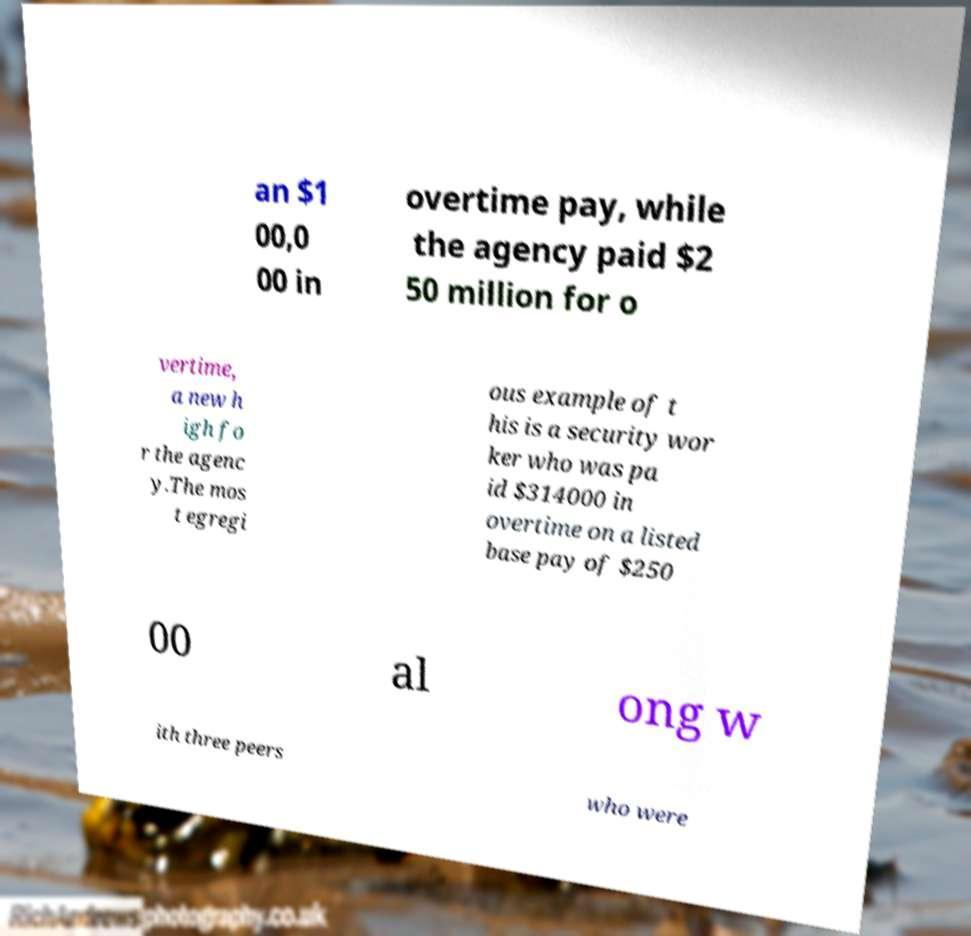Can you accurately transcribe the text from the provided image for me? an $1 00,0 00 in overtime pay, while the agency paid $2 50 million for o vertime, a new h igh fo r the agenc y.The mos t egregi ous example of t his is a security wor ker who was pa id $314000 in overtime on a listed base pay of $250 00 al ong w ith three peers who were 